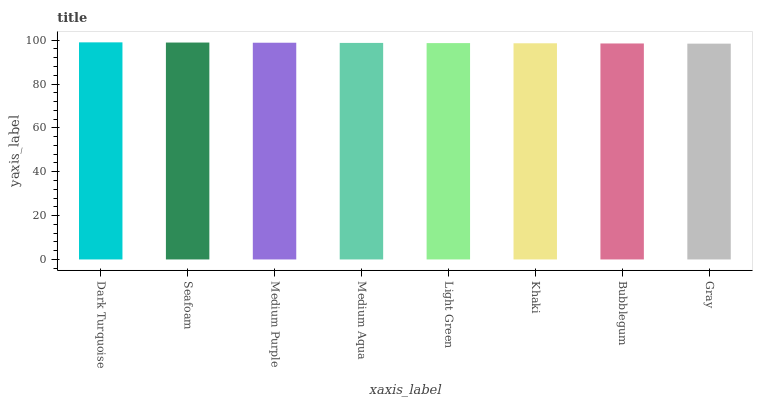Is Gray the minimum?
Answer yes or no. Yes. Is Dark Turquoise the maximum?
Answer yes or no. Yes. Is Seafoam the minimum?
Answer yes or no. No. Is Seafoam the maximum?
Answer yes or no. No. Is Dark Turquoise greater than Seafoam?
Answer yes or no. Yes. Is Seafoam less than Dark Turquoise?
Answer yes or no. Yes. Is Seafoam greater than Dark Turquoise?
Answer yes or no. No. Is Dark Turquoise less than Seafoam?
Answer yes or no. No. Is Medium Aqua the high median?
Answer yes or no. Yes. Is Light Green the low median?
Answer yes or no. Yes. Is Dark Turquoise the high median?
Answer yes or no. No. Is Dark Turquoise the low median?
Answer yes or no. No. 